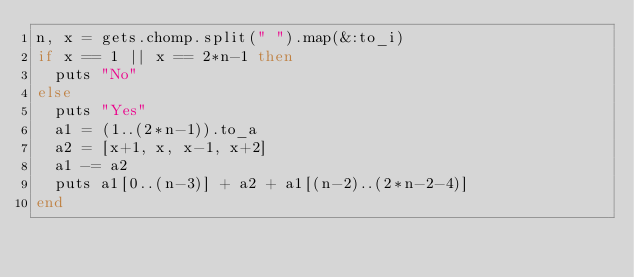<code> <loc_0><loc_0><loc_500><loc_500><_Ruby_>n, x = gets.chomp.split(" ").map(&:to_i)
if x == 1 || x == 2*n-1 then
  puts "No"
else
  puts "Yes"
  a1 = (1..(2*n-1)).to_a
  a2 = [x+1, x, x-1, x+2]
  a1 -= a2
  puts a1[0..(n-3)] + a2 + a1[(n-2)..(2*n-2-4)]
end</code> 